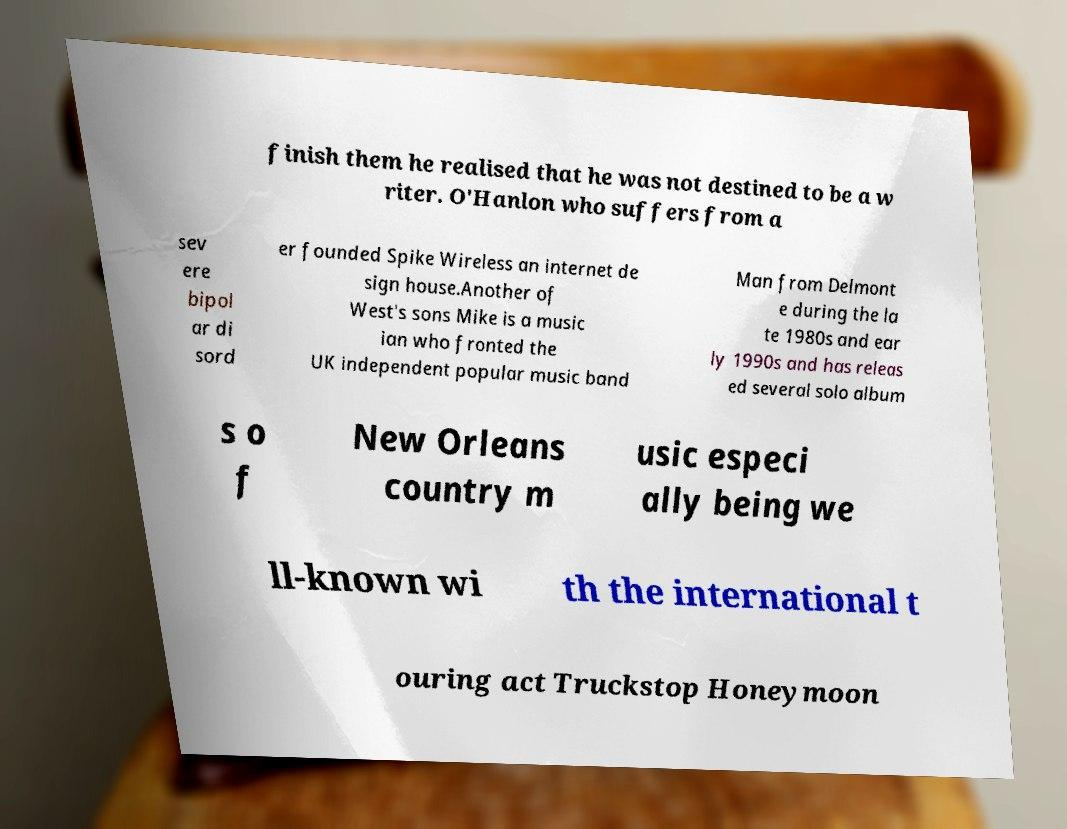Please read and relay the text visible in this image. What does it say? finish them he realised that he was not destined to be a w riter. O'Hanlon who suffers from a sev ere bipol ar di sord er founded Spike Wireless an internet de sign house.Another of West's sons Mike is a music ian who fronted the UK independent popular music band Man from Delmont e during the la te 1980s and ear ly 1990s and has releas ed several solo album s o f New Orleans country m usic especi ally being we ll-known wi th the international t ouring act Truckstop Honeymoon 